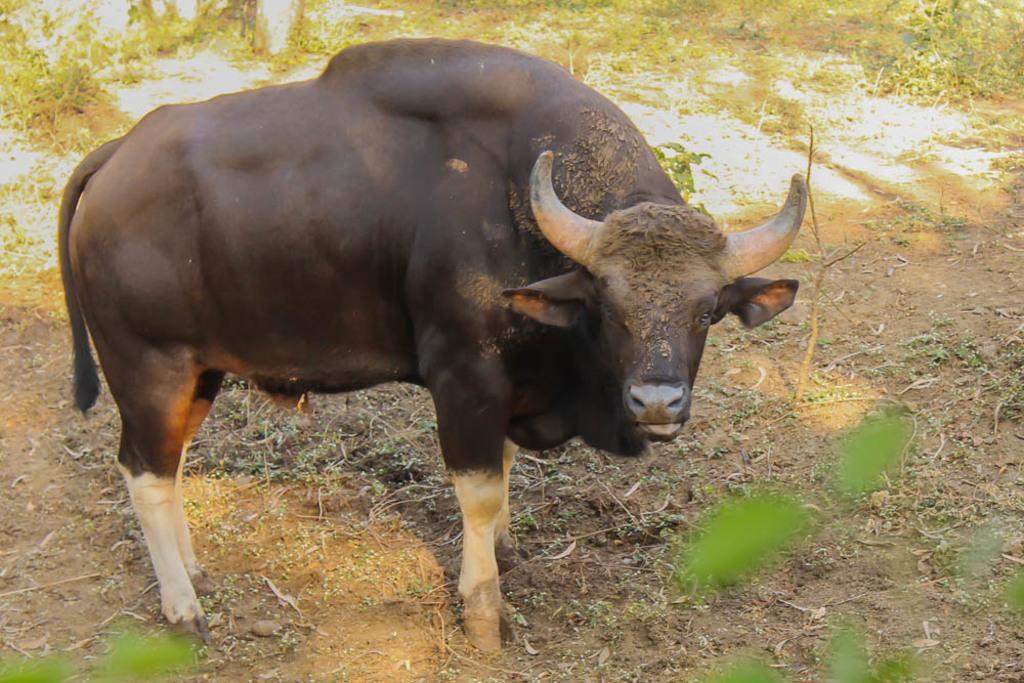Could you give a brief overview of what you see in this image? In the picture we can see a bison standing on the muddy path and behind it we can see the surface with grass plants. 